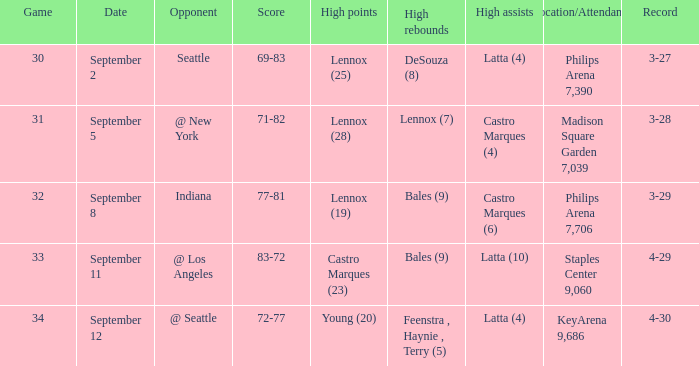What was the Location/Attendance on september 11? Staples Center 9,060. 